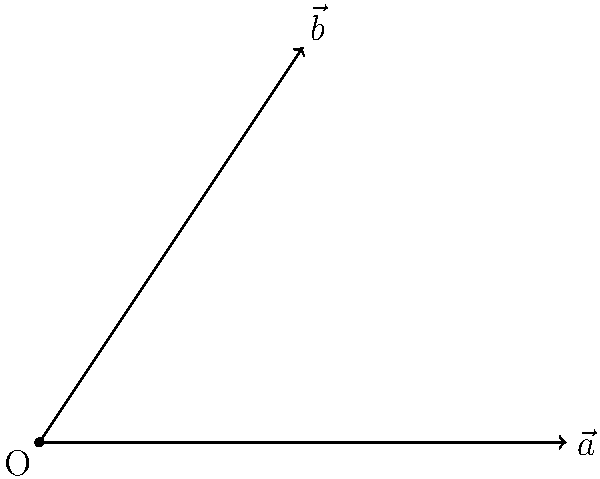In your art studio, you've set up two easels represented by vectors $\vec{a}$ and $\vec{b}$. Vector $\vec{a}$ has components (4, 0), and vector $\vec{b}$ has components (2, 3). What is the angle between these two vectors, representing the orientation of your easels? Express your answer in degrees, rounded to the nearest whole number. To find the angle between two vectors, we can use the dot product formula:

$$\cos \theta = \frac{\vec{a} \cdot \vec{b}}{|\vec{a}||\vec{b}|}$$

Step 1: Calculate the dot product $\vec{a} \cdot \vec{b}$
$\vec{a} \cdot \vec{b} = (4)(2) + (0)(3) = 8$

Step 2: Calculate the magnitudes of $\vec{a}$ and $\vec{b}$
$|\vec{a}| = \sqrt{4^2 + 0^2} = 4$
$|\vec{b}| = \sqrt{2^2 + 3^2} = \sqrt{13}$

Step 3: Substitute into the formula
$$\cos \theta = \frac{8}{4\sqrt{13}}$$

Step 4: Take the inverse cosine (arccos) of both sides
$$\theta = \arccos(\frac{8}{4\sqrt{13}})$$

Step 5: Calculate and convert to degrees
$$\theta \approx 0.8194 \text{ radians}$$
$$\theta \approx 46.97^\circ$$

Step 6: Round to the nearest whole number
$$\theta \approx 47^\circ$$
Answer: 47° 